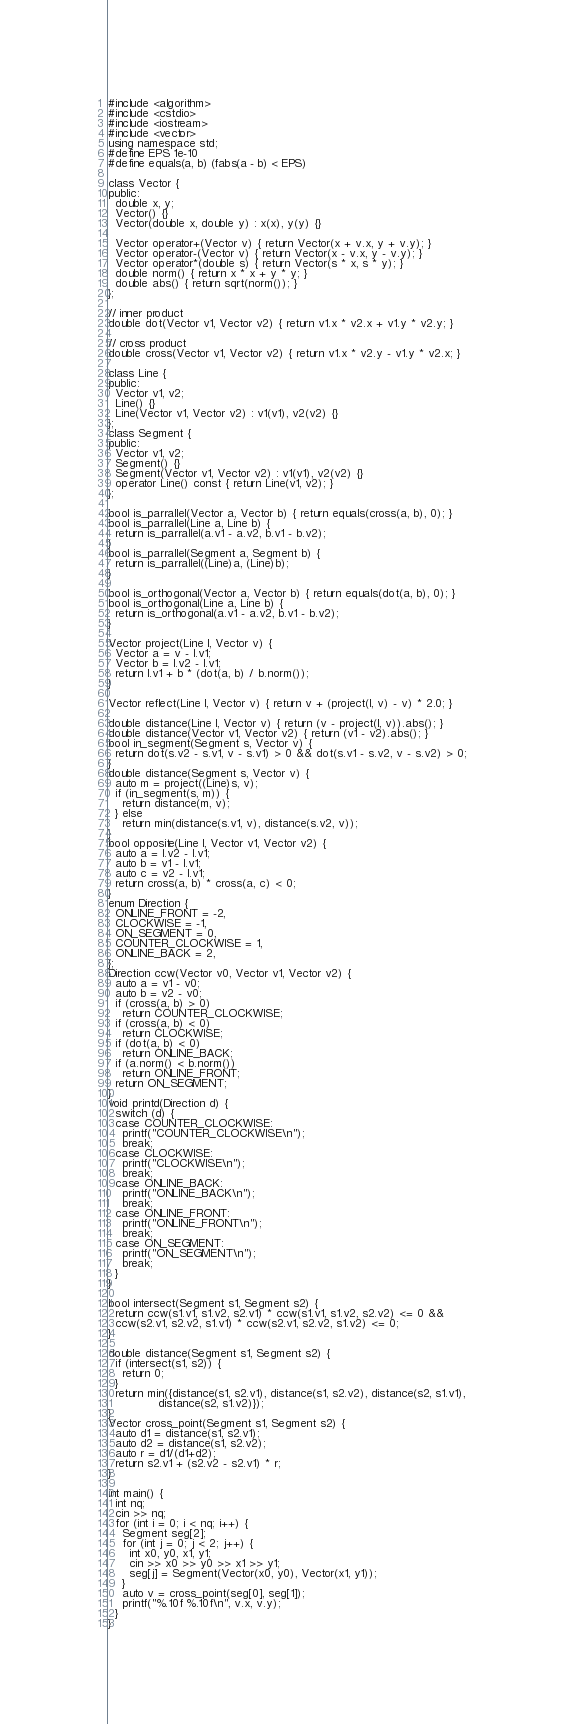Convert code to text. <code><loc_0><loc_0><loc_500><loc_500><_C++_>#include <algorithm>
#include <cstdio>
#include <iostream>
#include <vector>
using namespace std;
#define EPS 1e-10
#define equals(a, b) (fabs(a - b) < EPS)

class Vector {
public:
  double x, y;
  Vector() {}
  Vector(double x, double y) : x(x), y(y) {}

  Vector operator+(Vector v) { return Vector(x + v.x, y + v.y); }
  Vector operator-(Vector v) { return Vector(x - v.x, y - v.y); }
  Vector operator*(double s) { return Vector(s * x, s * y); }
  double norm() { return x * x + y * y; }
  double abs() { return sqrt(norm()); }
};

// inner product
double dot(Vector v1, Vector v2) { return v1.x * v2.x + v1.y * v2.y; }

// cross product
double cross(Vector v1, Vector v2) { return v1.x * v2.y - v1.y * v2.x; }

class Line {
public:
  Vector v1, v2;
  Line() {}
  Line(Vector v1, Vector v2) : v1(v1), v2(v2) {}
};
class Segment {
public:
  Vector v1, v2;
  Segment() {}
  Segment(Vector v1, Vector v2) : v1(v1), v2(v2) {}
  operator Line() const { return Line(v1, v2); }
};

bool is_parrallel(Vector a, Vector b) { return equals(cross(a, b), 0); }
bool is_parrallel(Line a, Line b) {
  return is_parrallel(a.v1 - a.v2, b.v1 - b.v2);
}
bool is_parrallel(Segment a, Segment b) {
  return is_parrallel((Line)a, (Line)b);
}

bool is_orthogonal(Vector a, Vector b) { return equals(dot(a, b), 0); }
bool is_orthogonal(Line a, Line b) {
  return is_orthogonal(a.v1 - a.v2, b.v1 - b.v2);
}

Vector project(Line l, Vector v) {
  Vector a = v - l.v1;
  Vector b = l.v2 - l.v1;
  return l.v1 + b * (dot(a, b) / b.norm());
}

Vector reflect(Line l, Vector v) { return v + (project(l, v) - v) * 2.0; }

double distance(Line l, Vector v) { return (v - project(l, v)).abs(); }
double distance(Vector v1, Vector v2) { return (v1 - v2).abs(); }
bool in_segment(Segment s, Vector v) {
  return dot(s.v2 - s.v1, v - s.v1) > 0 && dot(s.v1 - s.v2, v - s.v2) > 0;
}
double distance(Segment s, Vector v) {
  auto m = project((Line)s, v);
  if (in_segment(s, m)) {
    return distance(m, v);
  } else
    return min(distance(s.v1, v), distance(s.v2, v));
}
bool opposite(Line l, Vector v1, Vector v2) {
  auto a = l.v2 - l.v1;
  auto b = v1 - l.v1;
  auto c = v2 - l.v1;
  return cross(a, b) * cross(a, c) < 0;
}
enum Direction {
  ONLINE_FRONT = -2,
  CLOCKWISE = -1,
  ON_SEGMENT = 0,
  COUNTER_CLOCKWISE = 1,
  ONLINE_BACK = 2,
};
Direction ccw(Vector v0, Vector v1, Vector v2) {
  auto a = v1 - v0;
  auto b = v2 - v0;
  if (cross(a, b) > 0)
    return COUNTER_CLOCKWISE;
  if (cross(a, b) < 0)
    return CLOCKWISE;
  if (dot(a, b) < 0)
    return ONLINE_BACK;
  if (a.norm() < b.norm())
    return ONLINE_FRONT;
  return ON_SEGMENT;
}
void printd(Direction d) {
  switch (d) {
  case COUNTER_CLOCKWISE:
    printf("COUNTER_CLOCKWISE\n");
    break;
  case CLOCKWISE:
    printf("CLOCKWISE\n");
    break;
  case ONLINE_BACK:
    printf("ONLINE_BACK\n");
    break;
  case ONLINE_FRONT:
    printf("ONLINE_FRONT\n");
    break;
  case ON_SEGMENT:
    printf("ON_SEGMENT\n");
    break;
  }
}

bool intersect(Segment s1, Segment s2) {
  return ccw(s1.v1, s1.v2, s2.v1) * ccw(s1.v1, s1.v2, s2.v2) <= 0 &&
  ccw(s2.v1, s2.v2, s1.v1) * ccw(s2.v1, s2.v2, s1.v2) <= 0;
}

double distance(Segment s1, Segment s2) {
  if (intersect(s1, s2)) {
    return 0;
  }
  return min({distance(s1, s2.v1), distance(s1, s2.v2), distance(s2, s1.v1),
              distance(s2, s1.v2)});
}
Vector cross_point(Segment s1, Segment s2) {
  auto d1 = distance(s1, s2.v1);
  auto d2 = distance(s1, s2.v2);
  auto r = d1/(d1+d2);
  return s2.v1 + (s2.v2 - s2.v1) * r;
}

int main() {
  int nq;
  cin >> nq;
  for (int i = 0; i < nq; i++) {
    Segment seg[2];
    for (int j = 0; j < 2; j++) {
      int x0, y0, x1, y1;
      cin >> x0 >> y0 >> x1 >> y1;
      seg[j] = Segment(Vector(x0, y0), Vector(x1, y1));
    }
    auto v = cross_point(seg[0], seg[1]);
    printf("%.10f %.10f\n", v.x, v.y);
  }
}</code> 